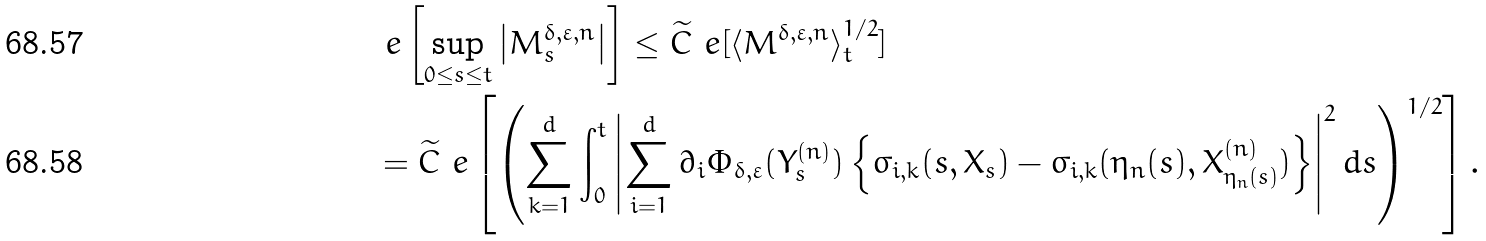<formula> <loc_0><loc_0><loc_500><loc_500>& \ e \left [ \sup _ { 0 \leq s \leq t } \left | M _ { s } ^ { \delta , \varepsilon , n } \right | \right ] \leq \widetilde { C } \ e [ \langle M ^ { \delta , \varepsilon , n } \rangle _ { t } ^ { 1 / 2 } ] \\ & = \widetilde { C } \ e \left [ \left ( \sum _ { k = 1 } ^ { d } \int _ { 0 } ^ { t } \left | \sum _ { i = 1 } ^ { d } \partial _ { i } \Phi _ { \delta , \varepsilon } ( Y _ { s } ^ { ( n ) } ) \left \{ \sigma _ { i , k } ( s , X _ { s } ) - \sigma _ { i , k } ( \eta _ { n } ( s ) , X _ { \eta _ { n } ( s ) } ^ { ( n ) } ) \right \} \right | ^ { 2 } d s \right ) ^ { 1 / 2 } \right ] .</formula> 